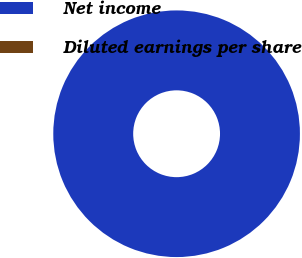<chart> <loc_0><loc_0><loc_500><loc_500><pie_chart><fcel>Net income<fcel>Diluted earnings per share<nl><fcel>100.0%<fcel>0.0%<nl></chart> 